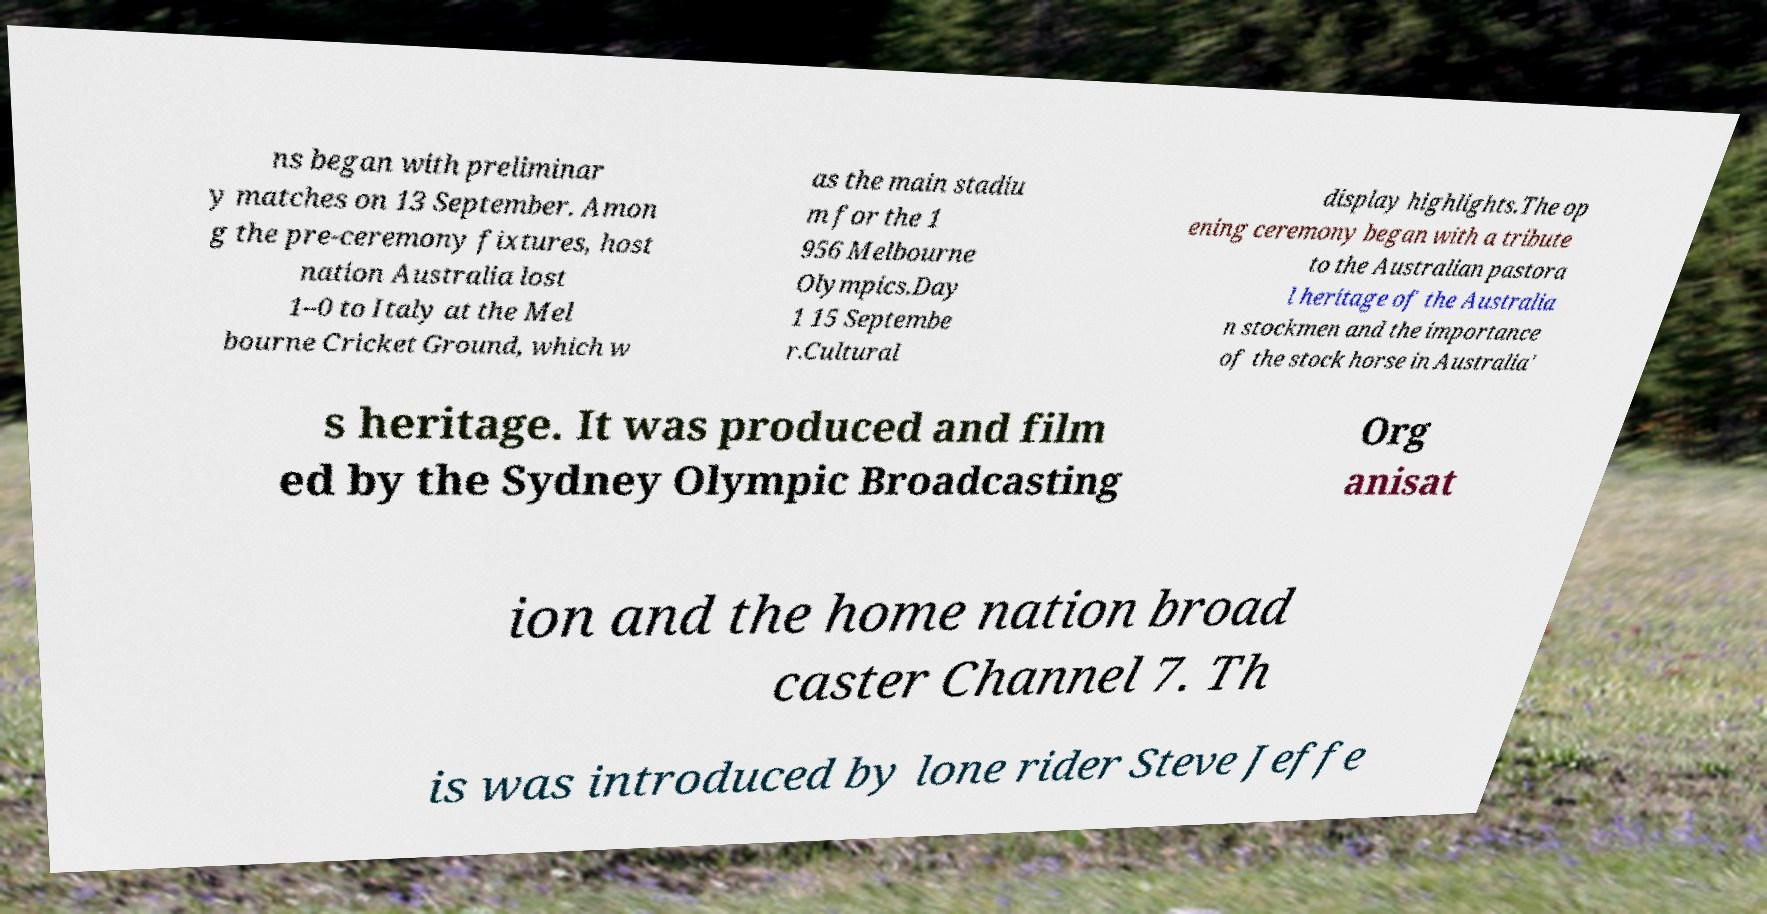Can you accurately transcribe the text from the provided image for me? ns began with preliminar y matches on 13 September. Amon g the pre-ceremony fixtures, host nation Australia lost 1–0 to Italy at the Mel bourne Cricket Ground, which w as the main stadiu m for the 1 956 Melbourne Olympics.Day 1 15 Septembe r.Cultural display highlights.The op ening ceremony began with a tribute to the Australian pastora l heritage of the Australia n stockmen and the importance of the stock horse in Australia' s heritage. It was produced and film ed by the Sydney Olympic Broadcasting Org anisat ion and the home nation broad caster Channel 7. Th is was introduced by lone rider Steve Jeffe 